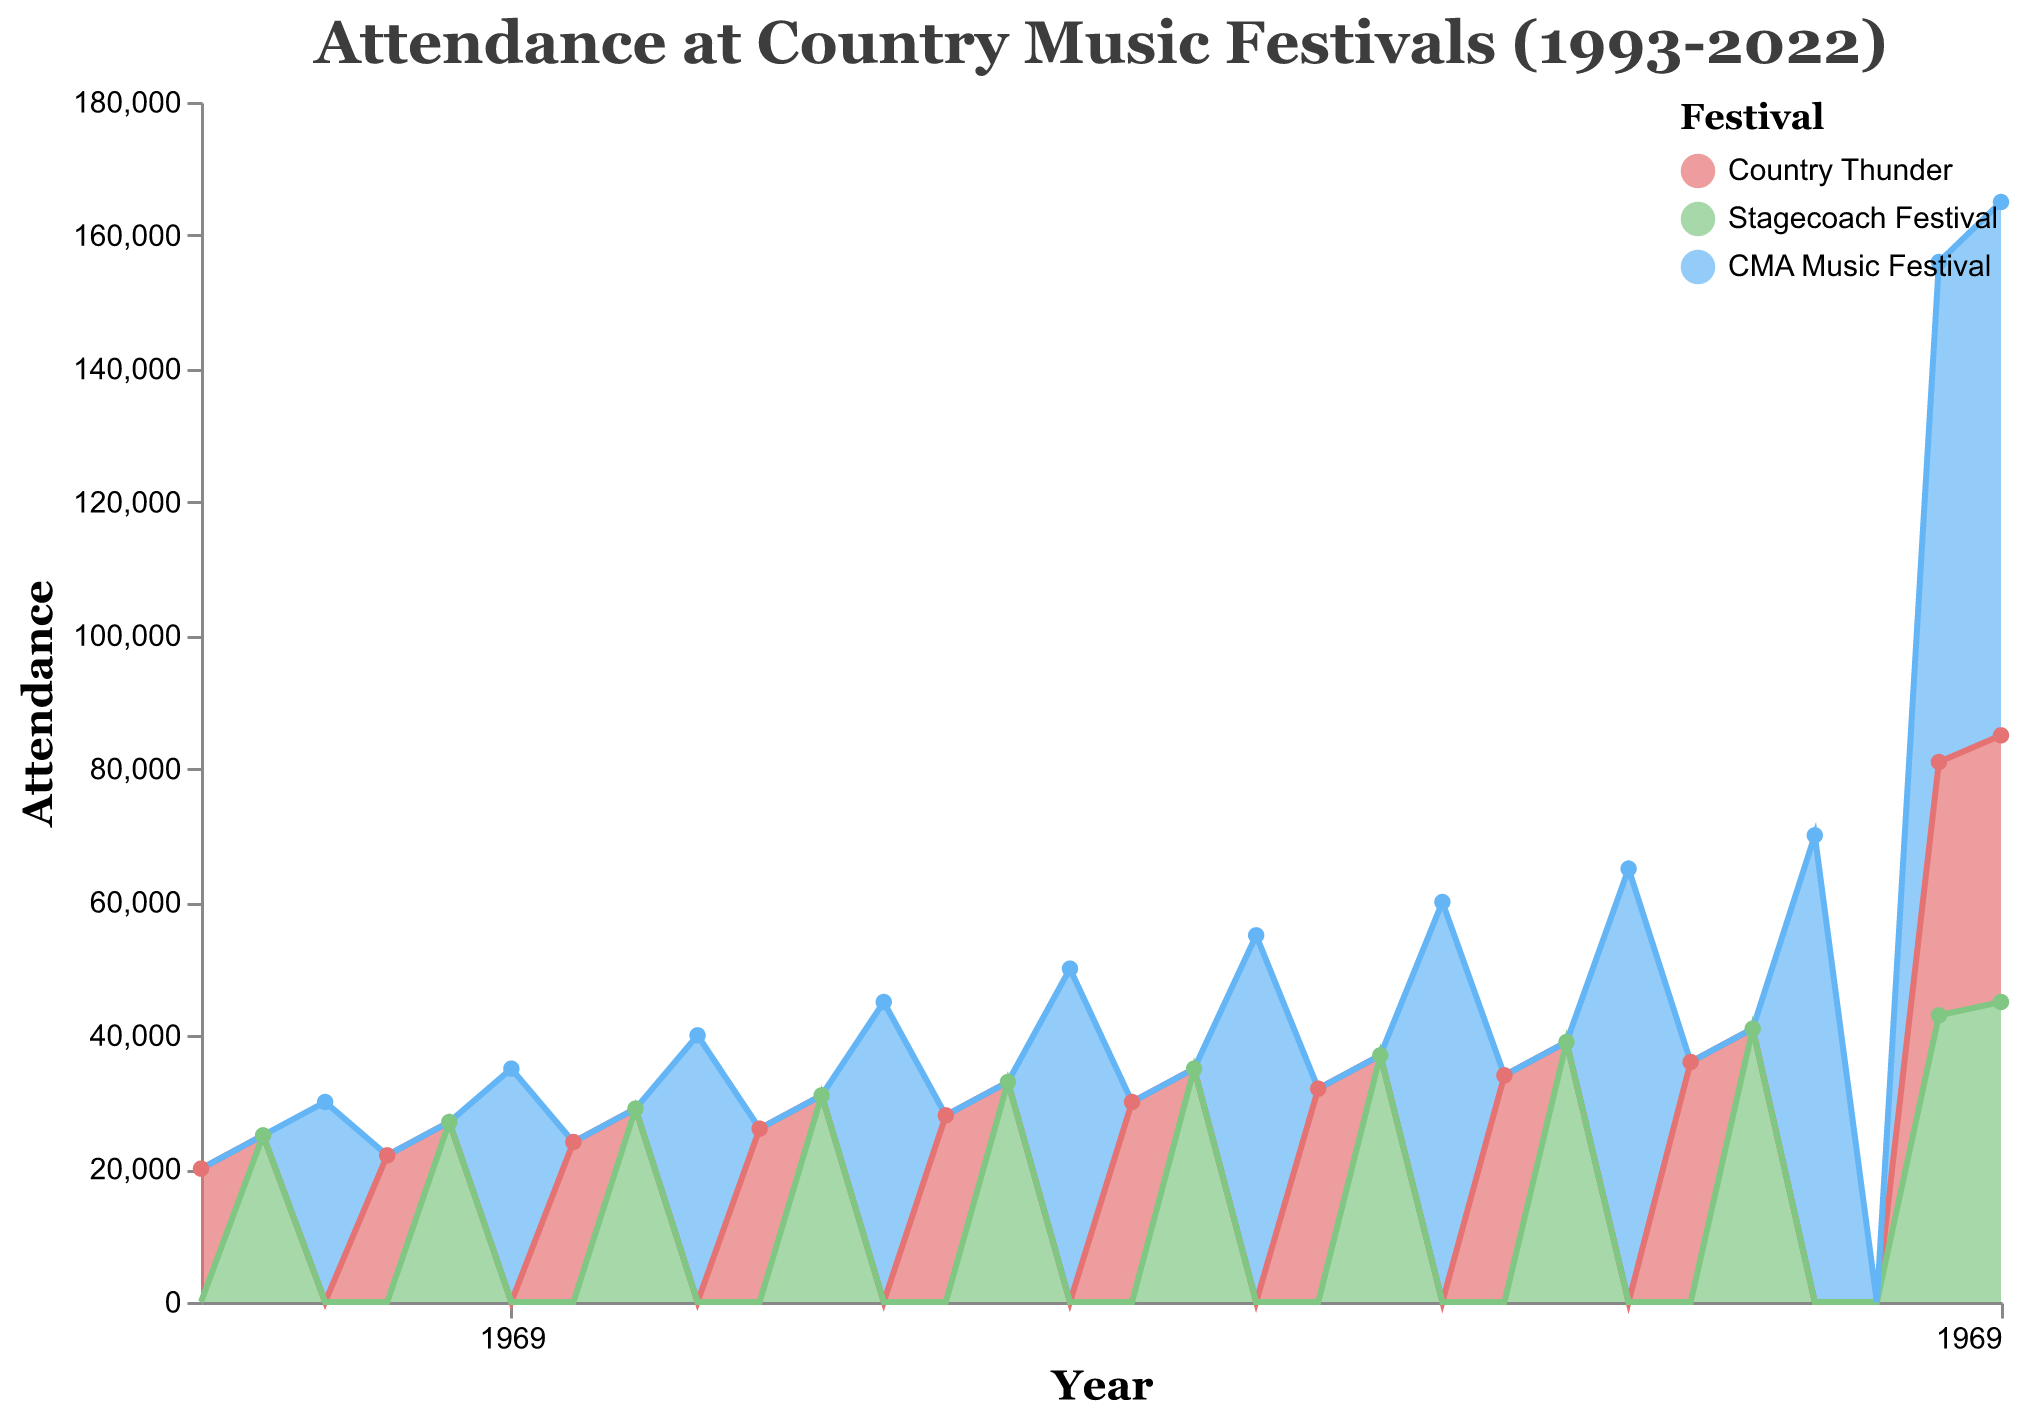What year had the highest attendance for the CMA Music Festival? Looking at the area representing the CMA Music Festival, it reaches its peak in 2022.
Answer: 2022 Which festival had the smallest attendance in 1993? By observing the 1993 data points, we find that only Country Thunder has attendance since the other two festivals are not shown in that year. Thus, Country Thunder had the smallest attendance.
Answer: Country Thunder What is the attendance difference between 2021 and 2020 for Country Thunder? In 2020, the attendance for Country Thunder was 0 due to cancellation. In 2021, it was 38,000. The difference is 38,000 - 0 = 38,000.
Answer: 38,000 How did the attendance of the Stagecoach Festival change from 2018 to 2022? The attendance for the Stagecoach Festival in 2018 was 41,000, and in 2022 it was 45,000. The change is 45,000 - 41,000 = 4,000 increase.
Answer: 4,000 increase Which festival had a continuous increase in attendance from 1993 to 2022 without any decrease? By examining all three festivals, we see that the CMA Music Festival shows a continuous increase, except for 2020 when it was cancelled.
Answer: CMA Music Festival How many festivals were cancelled in 2020? According to the plot, the number of cancelled festivals in 2020 can be seen where the attendance drops to 0 for three festivals: Country Thunder, Stagecoach Festival, and CMA Music Festival.
Answer: 3 What was the attendance trend for Country Thunder from 1993 to 2022? Observing the Country Thunder area, it shows variations with both increases and decreases over the years. It peaks in 2022 after a low in 1993. The trend includes ups and downs.
Answer: Varies with ups and downs Compare the attendance growth of the CMA Music Festival and the Stagecoach Festival from 1993 to 2022. CMA Music Festival attendance increased significantly from 30,000 to 80,000, while Stagecoach Festival grew from 25,000 to 45,000. CMA Music Festival saw a larger growth margin.
Answer: CMA Music Festival had larger growth What's the period during which the Stagecoach Festival attendance grew continuously without decreases? From the plot, the Stagecoach Festival attendance shows a continuous increase from 1994 (25,000) to 2016 (39,000) without any major dips.
Answer: 1994 to 2016 